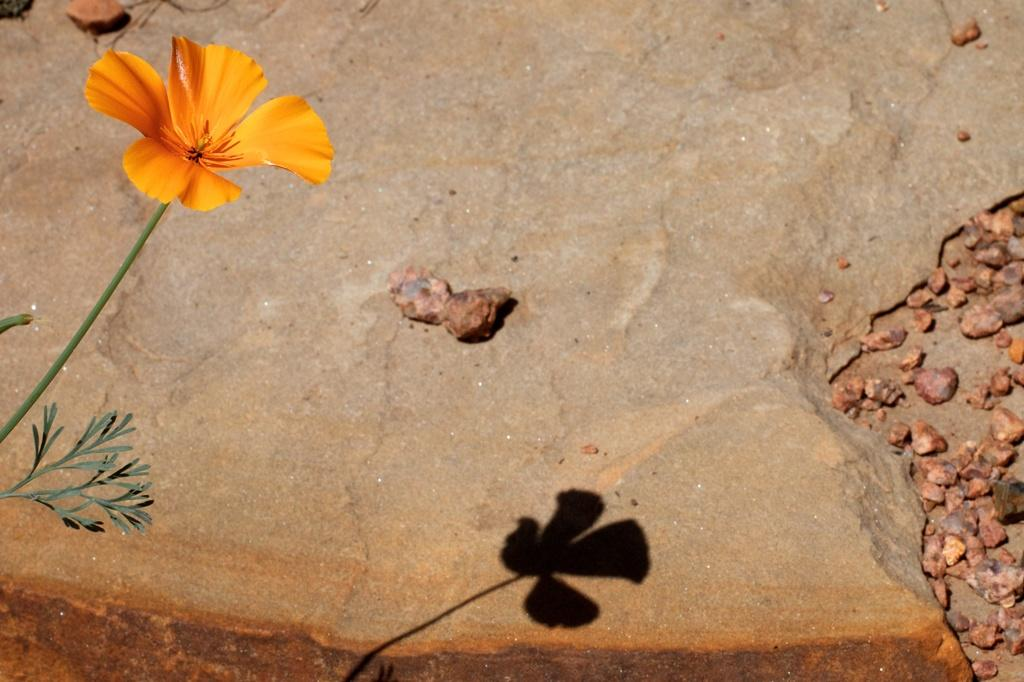What type of flower can be seen in the picture? There is a yellow flower in the picture. What other elements can be seen in the picture besides the flower? There are stones visible in the picture. Can you describe any other objects present in the picture? There are other objects present in the picture, but their specific details are not mentioned in the provided facts. What type of boat is sailing through the yellow flower in the picture? There is no boat present in the picture; it only features a yellow flower and stones. 